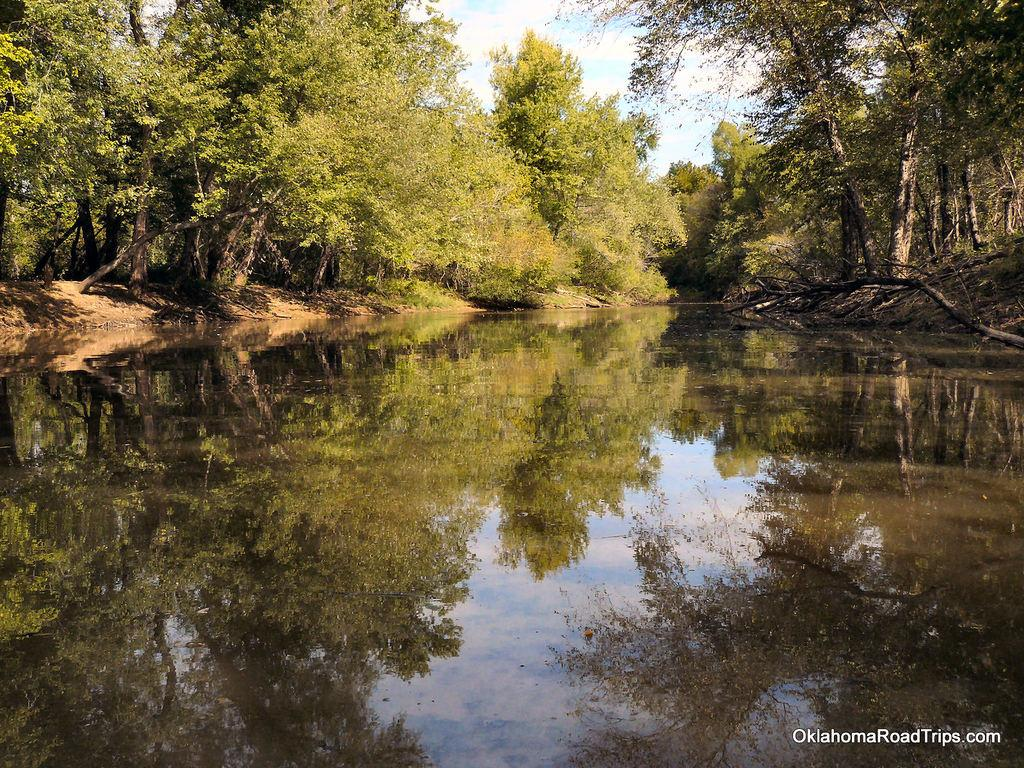What type of body of water is present in the image? There is a lake in the image. What surrounds the lake in the image? The lake is situated between trees. What is visible at the top of the image? The sky is visible at the top of the image. What type of house can be seen at the top of the image? There is no house present at the top of the image; only the sky is visible. 